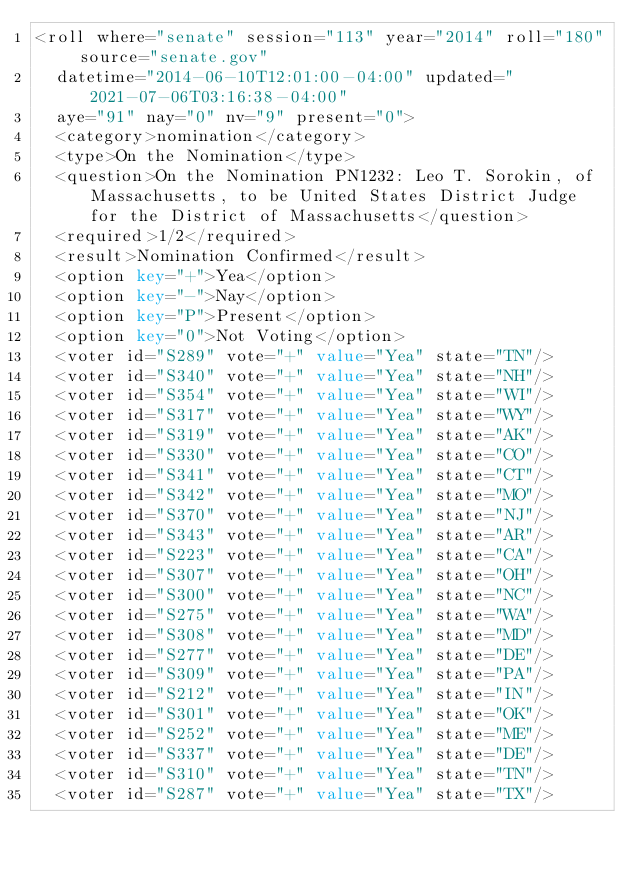Convert code to text. <code><loc_0><loc_0><loc_500><loc_500><_XML_><roll where="senate" session="113" year="2014" roll="180" source="senate.gov"
  datetime="2014-06-10T12:01:00-04:00" updated="2021-07-06T03:16:38-04:00"
  aye="91" nay="0" nv="9" present="0">
  <category>nomination</category>
  <type>On the Nomination</type>
  <question>On the Nomination PN1232: Leo T. Sorokin, of Massachusetts, to be United States District Judge for the District of Massachusetts</question>
  <required>1/2</required>
  <result>Nomination Confirmed</result>
  <option key="+">Yea</option>
  <option key="-">Nay</option>
  <option key="P">Present</option>
  <option key="0">Not Voting</option>
  <voter id="S289" vote="+" value="Yea" state="TN"/>
  <voter id="S340" vote="+" value="Yea" state="NH"/>
  <voter id="S354" vote="+" value="Yea" state="WI"/>
  <voter id="S317" vote="+" value="Yea" state="WY"/>
  <voter id="S319" vote="+" value="Yea" state="AK"/>
  <voter id="S330" vote="+" value="Yea" state="CO"/>
  <voter id="S341" vote="+" value="Yea" state="CT"/>
  <voter id="S342" vote="+" value="Yea" state="MO"/>
  <voter id="S370" vote="+" value="Yea" state="NJ"/>
  <voter id="S343" vote="+" value="Yea" state="AR"/>
  <voter id="S223" vote="+" value="Yea" state="CA"/>
  <voter id="S307" vote="+" value="Yea" state="OH"/>
  <voter id="S300" vote="+" value="Yea" state="NC"/>
  <voter id="S275" vote="+" value="Yea" state="WA"/>
  <voter id="S308" vote="+" value="Yea" state="MD"/>
  <voter id="S277" vote="+" value="Yea" state="DE"/>
  <voter id="S309" vote="+" value="Yea" state="PA"/>
  <voter id="S212" vote="+" value="Yea" state="IN"/>
  <voter id="S301" vote="+" value="Yea" state="OK"/>
  <voter id="S252" vote="+" value="Yea" state="ME"/>
  <voter id="S337" vote="+" value="Yea" state="DE"/>
  <voter id="S310" vote="+" value="Yea" state="TN"/>
  <voter id="S287" vote="+" value="Yea" state="TX"/></code> 